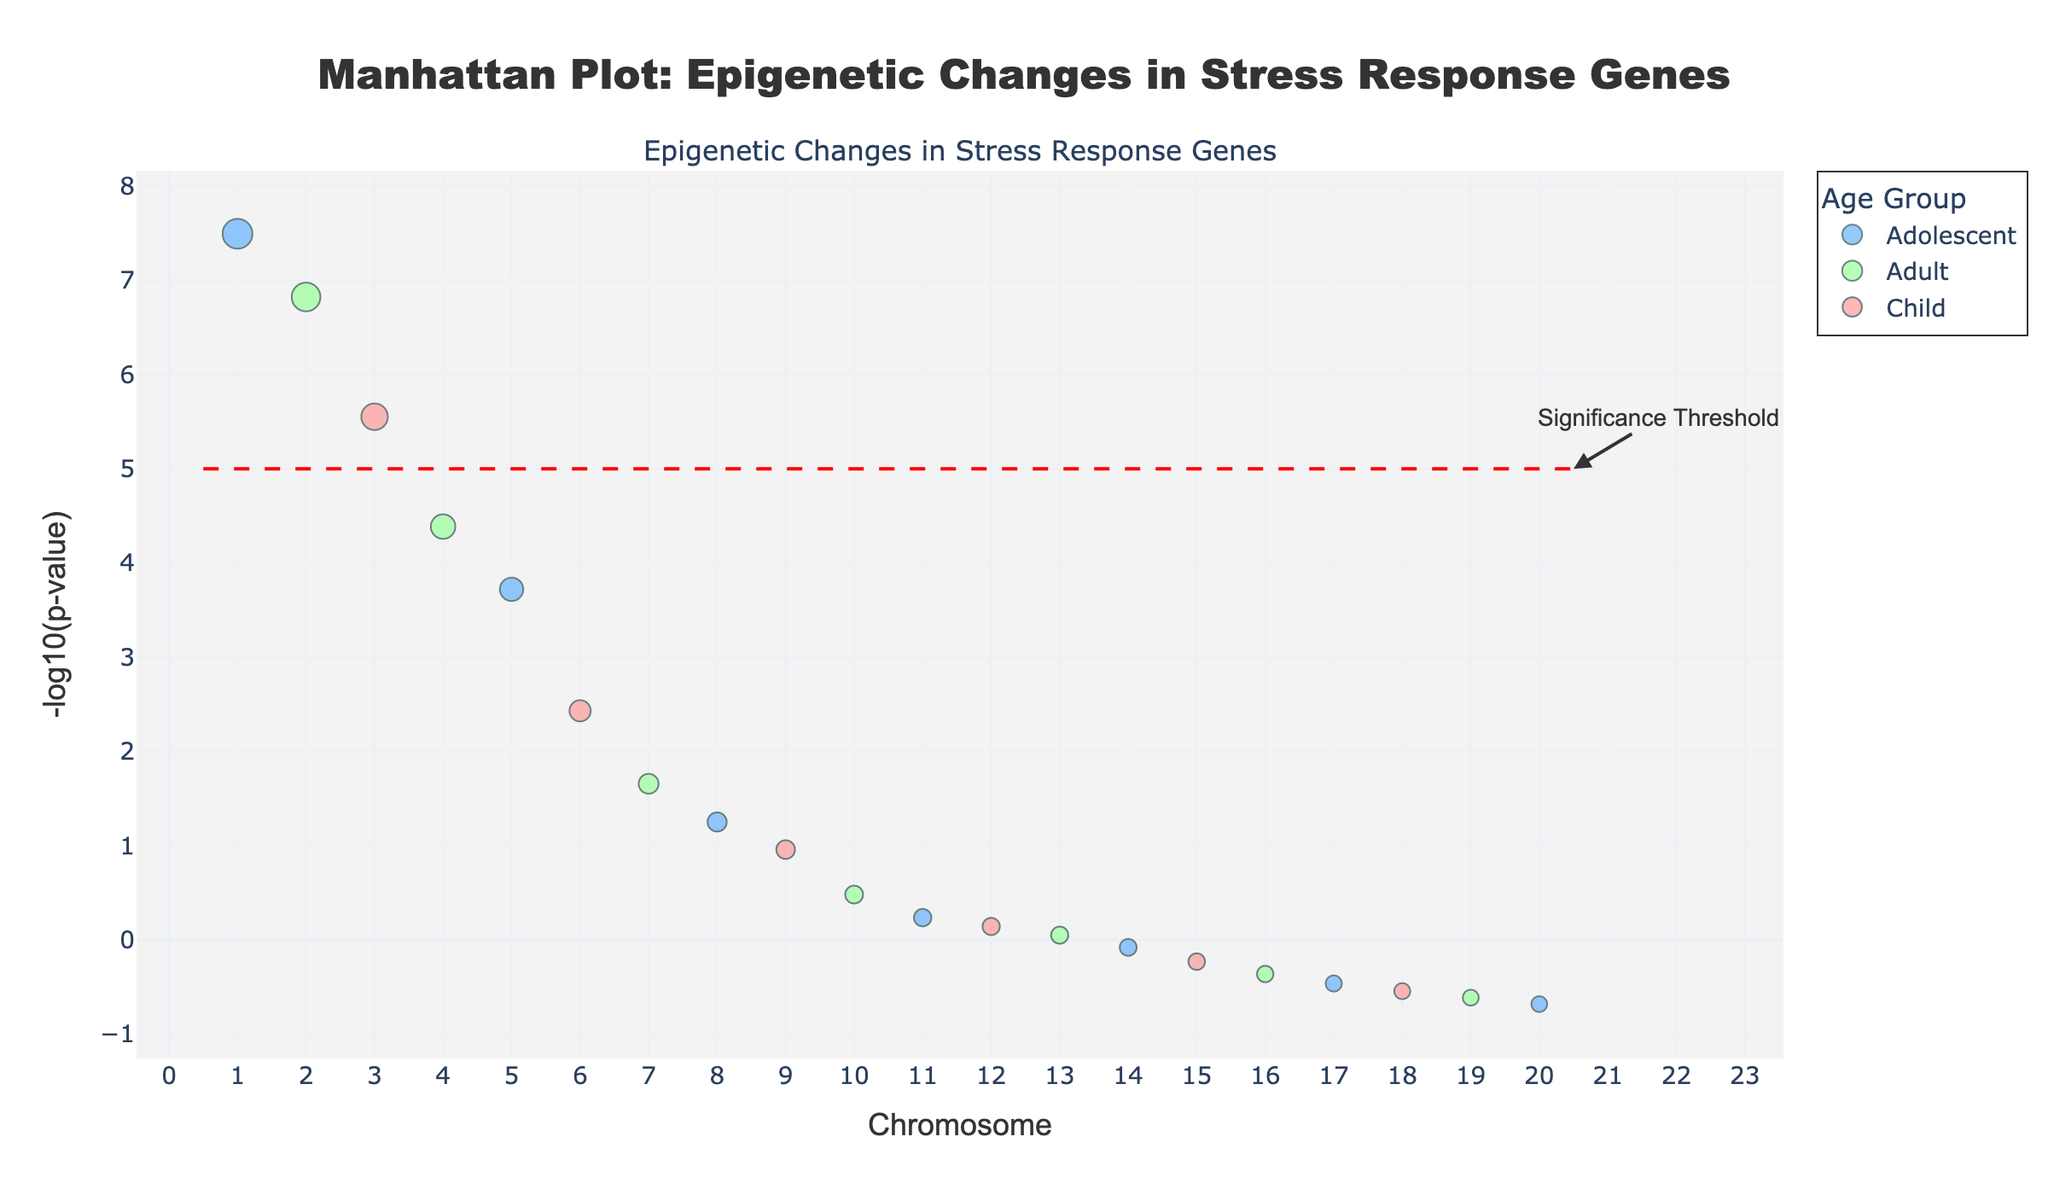What is the title of the figure? The title of the figure is typically found at the top and is used to describe the overall content of the plot. In this case, the title reads "Manhattan Plot: Epigenetic Changes in Stress Response Genes."
Answer: Manhattan Plot: Epigenetic Changes in Stress Response Genes What does the x-axis represent? The x-axis label indicates what is plotted along the horizontal axis. Here, the x-axis represents "Chromosome," showing the distribution of genes across different chromosomes.
Answer: Chromosome What does the y-axis represent? The y-axis label indicates what is plotted along the vertical axis. In this plot, the y-axis represents "-log10(p-value)," which measures the statistical significance of the genes' p-values.
Answer: -log10(p-value) How are different age groups represented in the plot? Different age groups are represented using distinct colors. For example, 'Child' is colored in pink, 'Adolescent' in blue, and 'Adult' in green.
Answer: Child: pink, Adolescent: blue, Adult: green How many data points are above the significance threshold line? The threshold line is set at -log10(p-value) = 5. Points above this line are considered statistically significant. By counting the points above the line, we see there are 2 data points.
Answer: 2 Which gene has the lowest p-value? The lowest p-value corresponds to the highest value on the -log10(p-value) scale. The gene at the highest point is SLC6A4 in Adolescents.
Answer: SLC6A4 How many genes have a p-value below 0.001 across all age groups? A p-value below 0.001 corresponds to -log10(p-value) above 3. The data shows that there are 3 such genes: SLC6A4, FKBP5, NR3C1.
Answer: 3 Which age group has the most genes with statistically significant changes? Statistically significant changes are above the threshold line. Here, we count the points above the threshold for each age group. Adolescents have 1, Adults have 1, and Children have 0. Both Adolescents and Adults have the most genes with 1 significant change each.
Answer: Adolescents and Adults Compare the significance of FKBP5 between Adults and Children. FKBP5 appears twice, for Adults and Children. By comparing their y-values (-log10(p-value)), FKBP5 in Adults (1.5e-7, y = 6.82) is more significant than in Children (3.5e-0, y = 0.46).
Answer: More significant in Adults Which chromosome has the highest number of significant genes? To find this, count the significant genes (above the threshold) per chromosome. Chromosome 1 and 2 each have 1 significant gene. Since it's a tie between multiple chromosomes each with 1 significant gene, the answer should denote that comparison.
Answer: Chromosome 1 and Chromium 2 